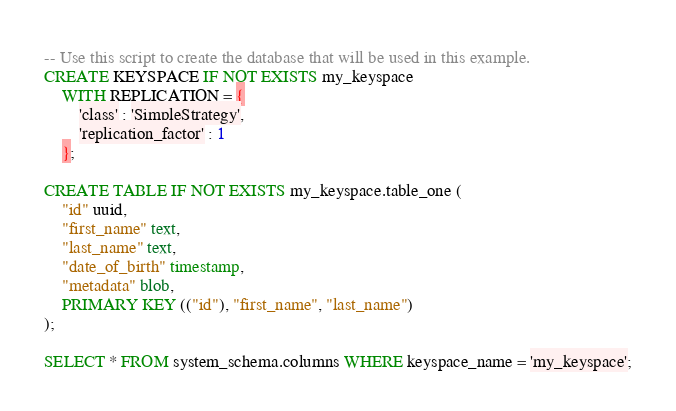Convert code to text. <code><loc_0><loc_0><loc_500><loc_500><_SQL_>-- Use this script to create the database that will be used in this example.
CREATE KEYSPACE IF NOT EXISTS my_keyspace
    WITH REPLICATION = {
        'class' : 'SimpleStrategy',
        'replication_factor' : 1
    };

CREATE TABLE IF NOT EXISTS my_keyspace.table_one (
	"id" uuid,
	"first_name" text,
	"last_name" text,
	"date_of_birth" timestamp,
	"metadata" blob,
	PRIMARY KEY (("id"), "first_name", "last_name")
);

SELECT * FROM system_schema.columns WHERE keyspace_name = 'my_keyspace';</code> 